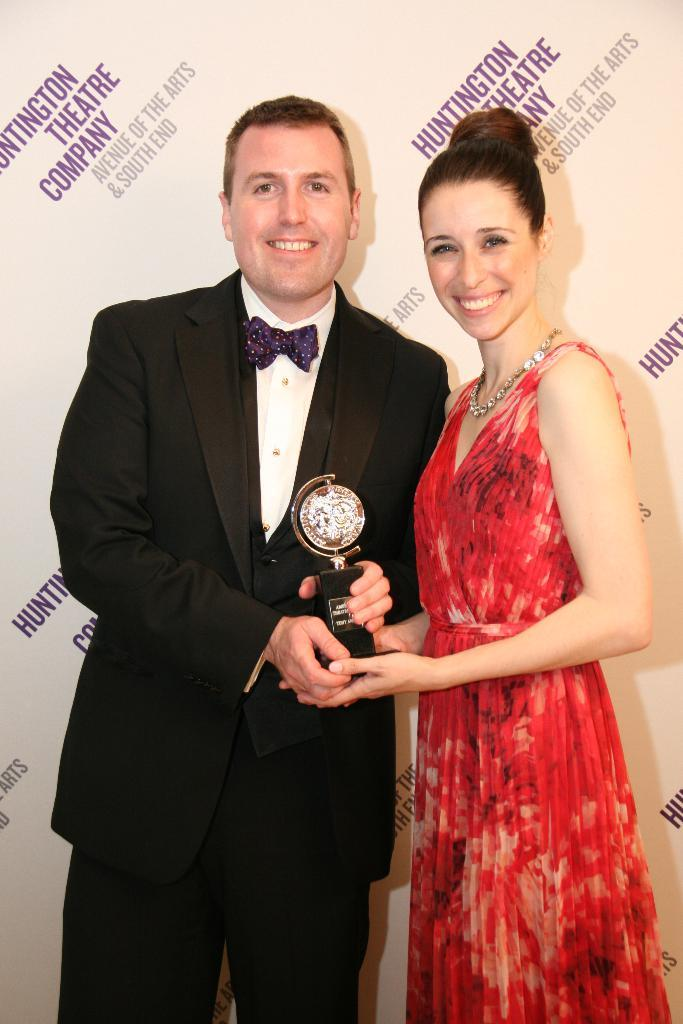<image>
Offer a succinct explanation of the picture presented. A couple dressed in formal wearing holding a award standing in front of a poster from the Huntington Theatre Company. 